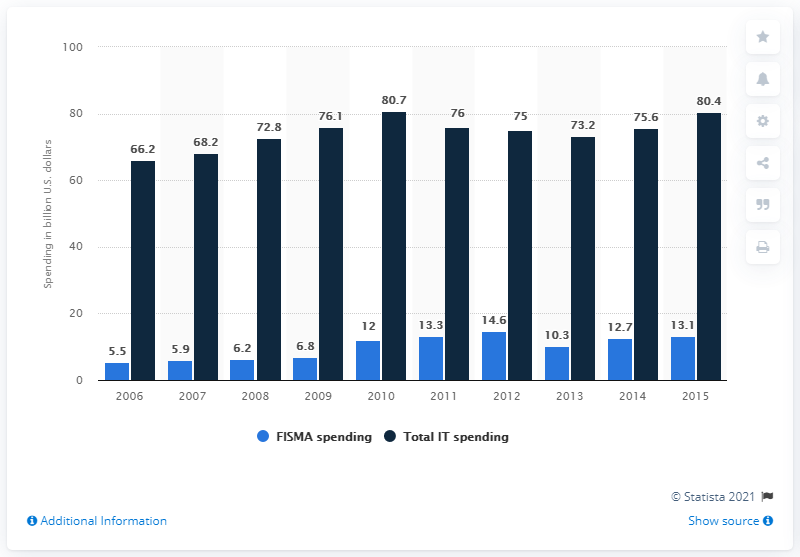Mention a couple of crucial points in this snapshot. The average of Total IT spending from 2010 to 2011 was approximately 78.35 billion U.S. dollars. In 2009, the Federal Information Security Management Act (FISMA) spending was $6.8 billion in the United States. In 2015, the United States government spent approximately 13.1 million dollars on FISMA (Federal Information Security Management Act). 